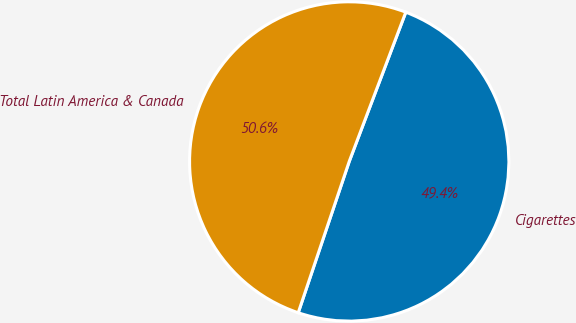Convert chart. <chart><loc_0><loc_0><loc_500><loc_500><pie_chart><fcel>Cigarettes<fcel>Total Latin America & Canada<nl><fcel>49.41%<fcel>50.59%<nl></chart> 